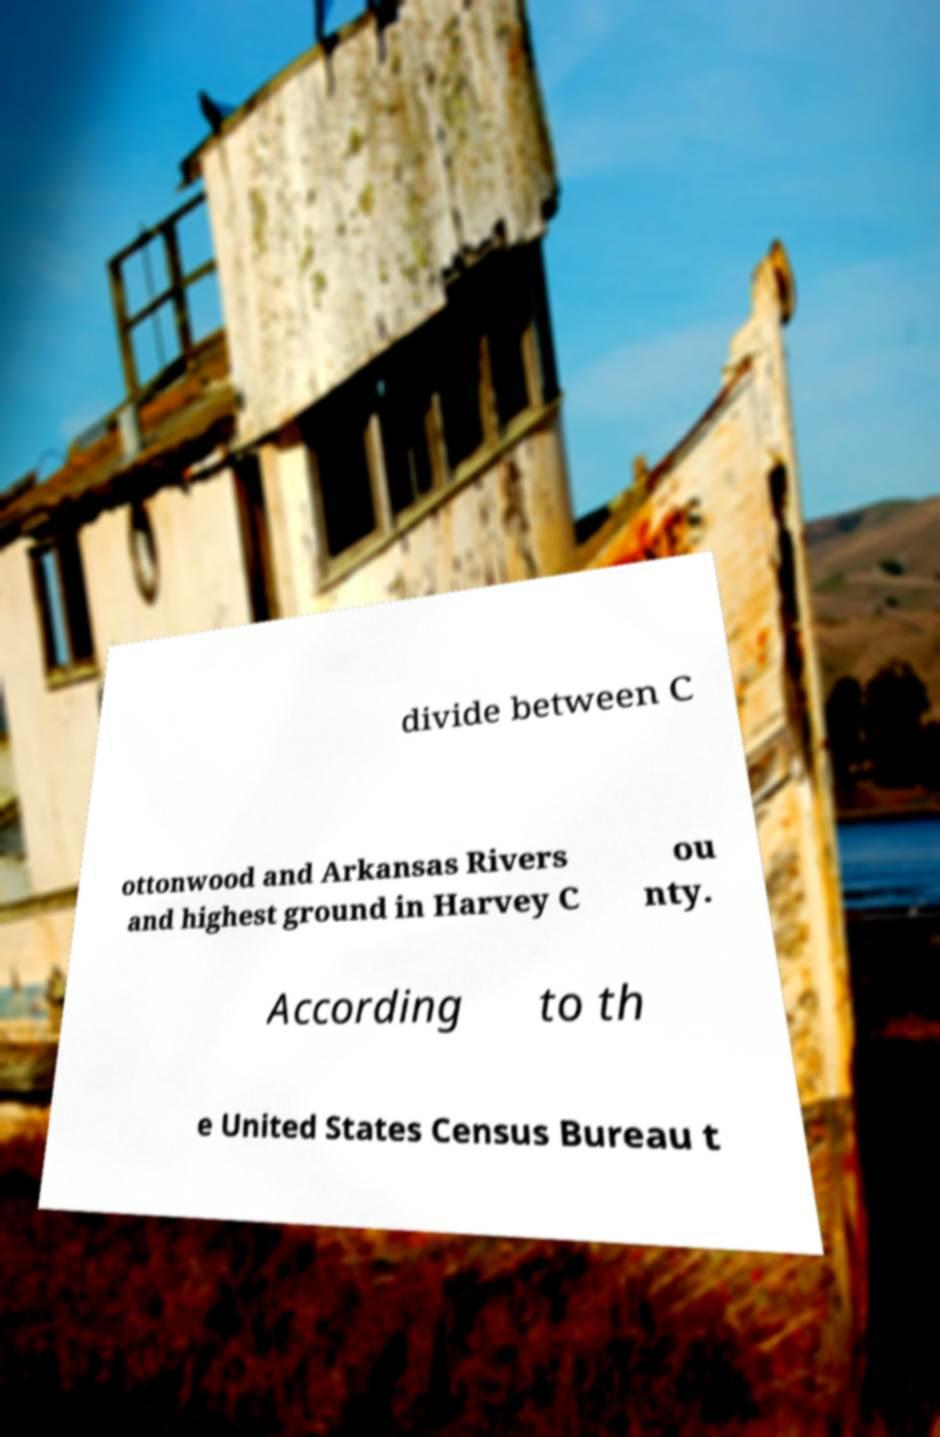What messages or text are displayed in this image? I need them in a readable, typed format. divide between C ottonwood and Arkansas Rivers and highest ground in Harvey C ou nty. According to th e United States Census Bureau t 